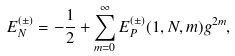Convert formula to latex. <formula><loc_0><loc_0><loc_500><loc_500>E _ { N } ^ { ( \pm ) } = - \frac { 1 } { 2 } + \sum _ { m = 0 } ^ { \infty } E _ { P } ^ { ( \pm ) } ( 1 , N , m ) g ^ { 2 m } ,</formula> 